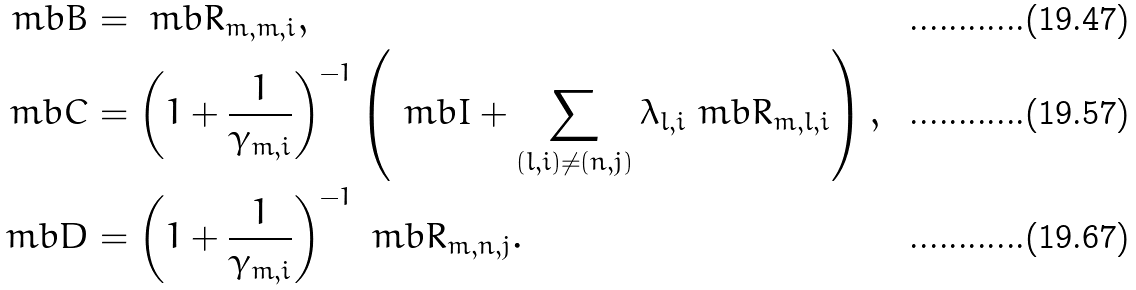Convert formula to latex. <formula><loc_0><loc_0><loc_500><loc_500>\ m b { B } & = \ m b { R } _ { m , m , i } , \\ \ m b { C } & = \left ( 1 + \frac { 1 } { \gamma _ { m , i } } \right ) ^ { - 1 } \left ( \ m b { I } + \sum _ { ( l , i ) \neq ( n , j ) } \lambda _ { l , i } \ m b { R } _ { m , l , i } \right ) , \\ \ m b { D } & = \left ( 1 + \frac { 1 } { \gamma _ { m , i } } \right ) ^ { - 1 } \ m b { R } _ { m , n , j } .</formula> 